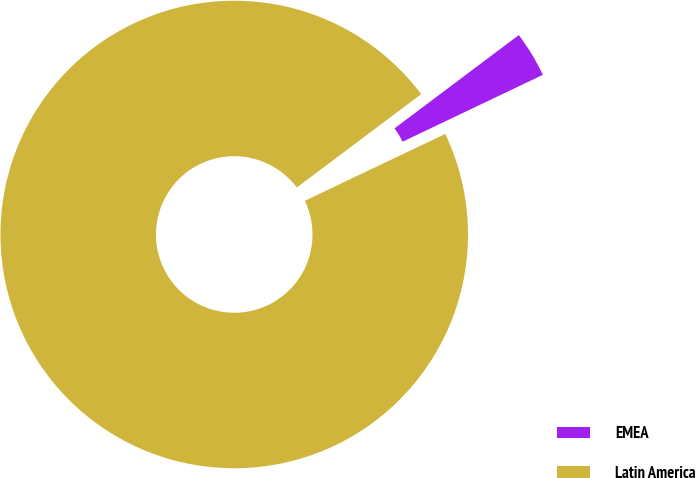Convert chart to OTSL. <chart><loc_0><loc_0><loc_500><loc_500><pie_chart><fcel>EMEA<fcel>Latin America<nl><fcel>3.17%<fcel>96.83%<nl></chart> 